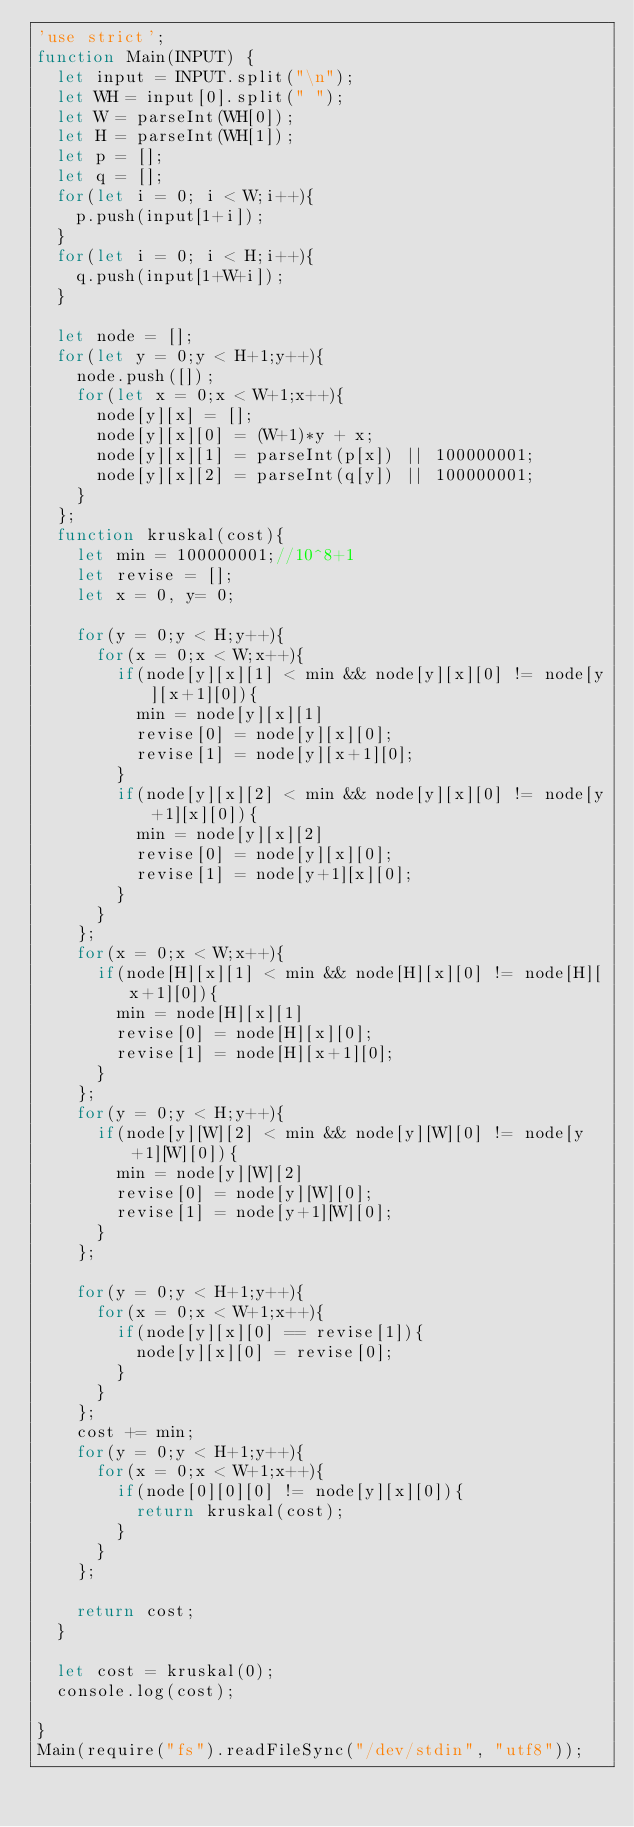<code> <loc_0><loc_0><loc_500><loc_500><_JavaScript_>'use strict';
function Main(INPUT) {
  let input = INPUT.split("\n");
  let WH = input[0].split(" ");
  let W = parseInt(WH[0]);
  let H = parseInt(WH[1]);
  let p = [];
  let q = [];
  for(let i = 0; i < W;i++){
    p.push(input[1+i]);
  }
  for(let i = 0; i < H;i++){
    q.push(input[1+W+i]);
  }

  let node = [];
  for(let y = 0;y < H+1;y++){
    node.push([]);
    for(let x = 0;x < W+1;x++){
      node[y][x] = [];
      node[y][x][0] = (W+1)*y + x;
      node[y][x][1] = parseInt(p[x]) || 100000001;
      node[y][x][2] = parseInt(q[y]) || 100000001;
    }
  };
  function kruskal(cost){
    let min = 100000001;//10^8+1
    let revise = [];
    let x = 0, y= 0;

    for(y = 0;y < H;y++){
      for(x = 0;x < W;x++){
        if(node[y][x][1] < min && node[y][x][0] != node[y][x+1][0]){
          min = node[y][x][1]
          revise[0] = node[y][x][0];
          revise[1] = node[y][x+1][0];
        }
        if(node[y][x][2] < min && node[y][x][0] != node[y+1][x][0]){
          min = node[y][x][2]
          revise[0] = node[y][x][0];
          revise[1] = node[y+1][x][0];
        }
      }
    };
    for(x = 0;x < W;x++){
      if(node[H][x][1] < min && node[H][x][0] != node[H][x+1][0]){
        min = node[H][x][1]
        revise[0] = node[H][x][0];
        revise[1] = node[H][x+1][0];
      }
    };
    for(y = 0;y < H;y++){
      if(node[y][W][2] < min && node[y][W][0] != node[y+1][W][0]){
        min = node[y][W][2]
        revise[0] = node[y][W][0];
        revise[1] = node[y+1][W][0];
      }
    };

    for(y = 0;y < H+1;y++){
      for(x = 0;x < W+1;x++){
        if(node[y][x][0] == revise[1]){
          node[y][x][0] = revise[0];
        }
      }
    };
    cost += min;
    for(y = 0;y < H+1;y++){
      for(x = 0;x < W+1;x++){
        if(node[0][0][0] != node[y][x][0]){
          return kruskal(cost);
        }
      }
    };

    return cost;
  }

  let cost = kruskal(0);
  console.log(cost);

}
Main(require("fs").readFileSync("/dev/stdin", "utf8"));</code> 